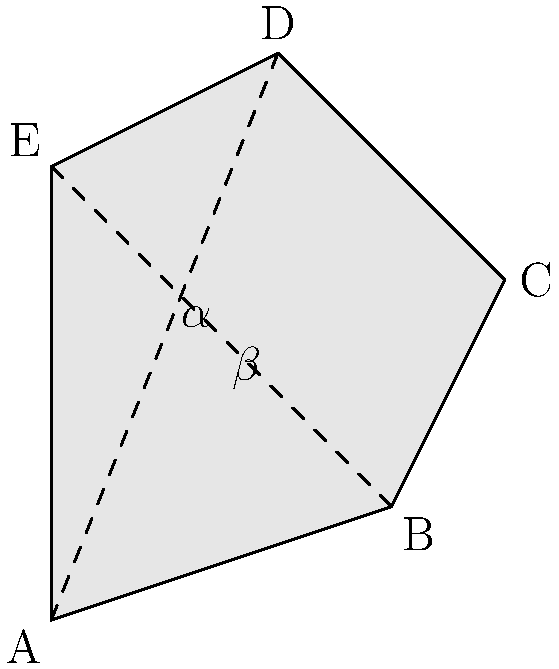In this simplified 2D representation of the Arabian Peninsula, imagine folding along the dashed lines to create a 3D shape. If angle $\alpha$ is 60°, what would be the measure of angle $\beta$ in the resulting 3D shape? To solve this problem, let's follow these steps:

1. Recognize that the dashed lines represent the fold lines that will meet in the 3D shape.

2. In a 3D shape, the sum of the angles around a point is always 360°.

3. The two angles $\alpha$ and $\beta$ will form a complete angle around a point in the 3D shape.

4. Therefore, we can set up the equation:
   $\alpha + \beta = 360°$

5. We are given that $\alpha = 60°$

6. Substitute this into our equation:
   $60° + \beta = 360°$

7. Solve for $\beta$:
   $\beta = 360° - 60° = 300°$

This problem relates to your background in Arabic Studies as it uses the Arabian Peninsula as a context, while also testing spatial reasoning skills that might have been developed during your studies at BYU.
Answer: 300° 